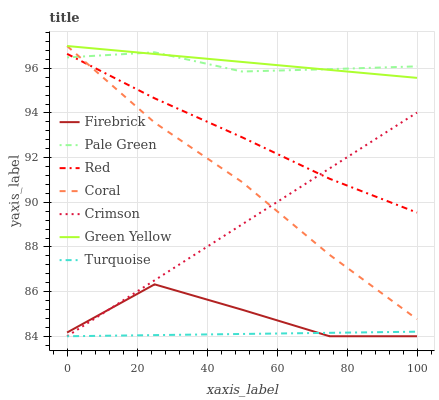Does Firebrick have the minimum area under the curve?
Answer yes or no. No. Does Firebrick have the maximum area under the curve?
Answer yes or no. No. Is Pale Green the smoothest?
Answer yes or no. No. Is Pale Green the roughest?
Answer yes or no. No. Does Pale Green have the lowest value?
Answer yes or no. No. Does Firebrick have the highest value?
Answer yes or no. No. Is Turquoise less than Pale Green?
Answer yes or no. Yes. Is Pale Green greater than Turquoise?
Answer yes or no. Yes. Does Turquoise intersect Pale Green?
Answer yes or no. No. 